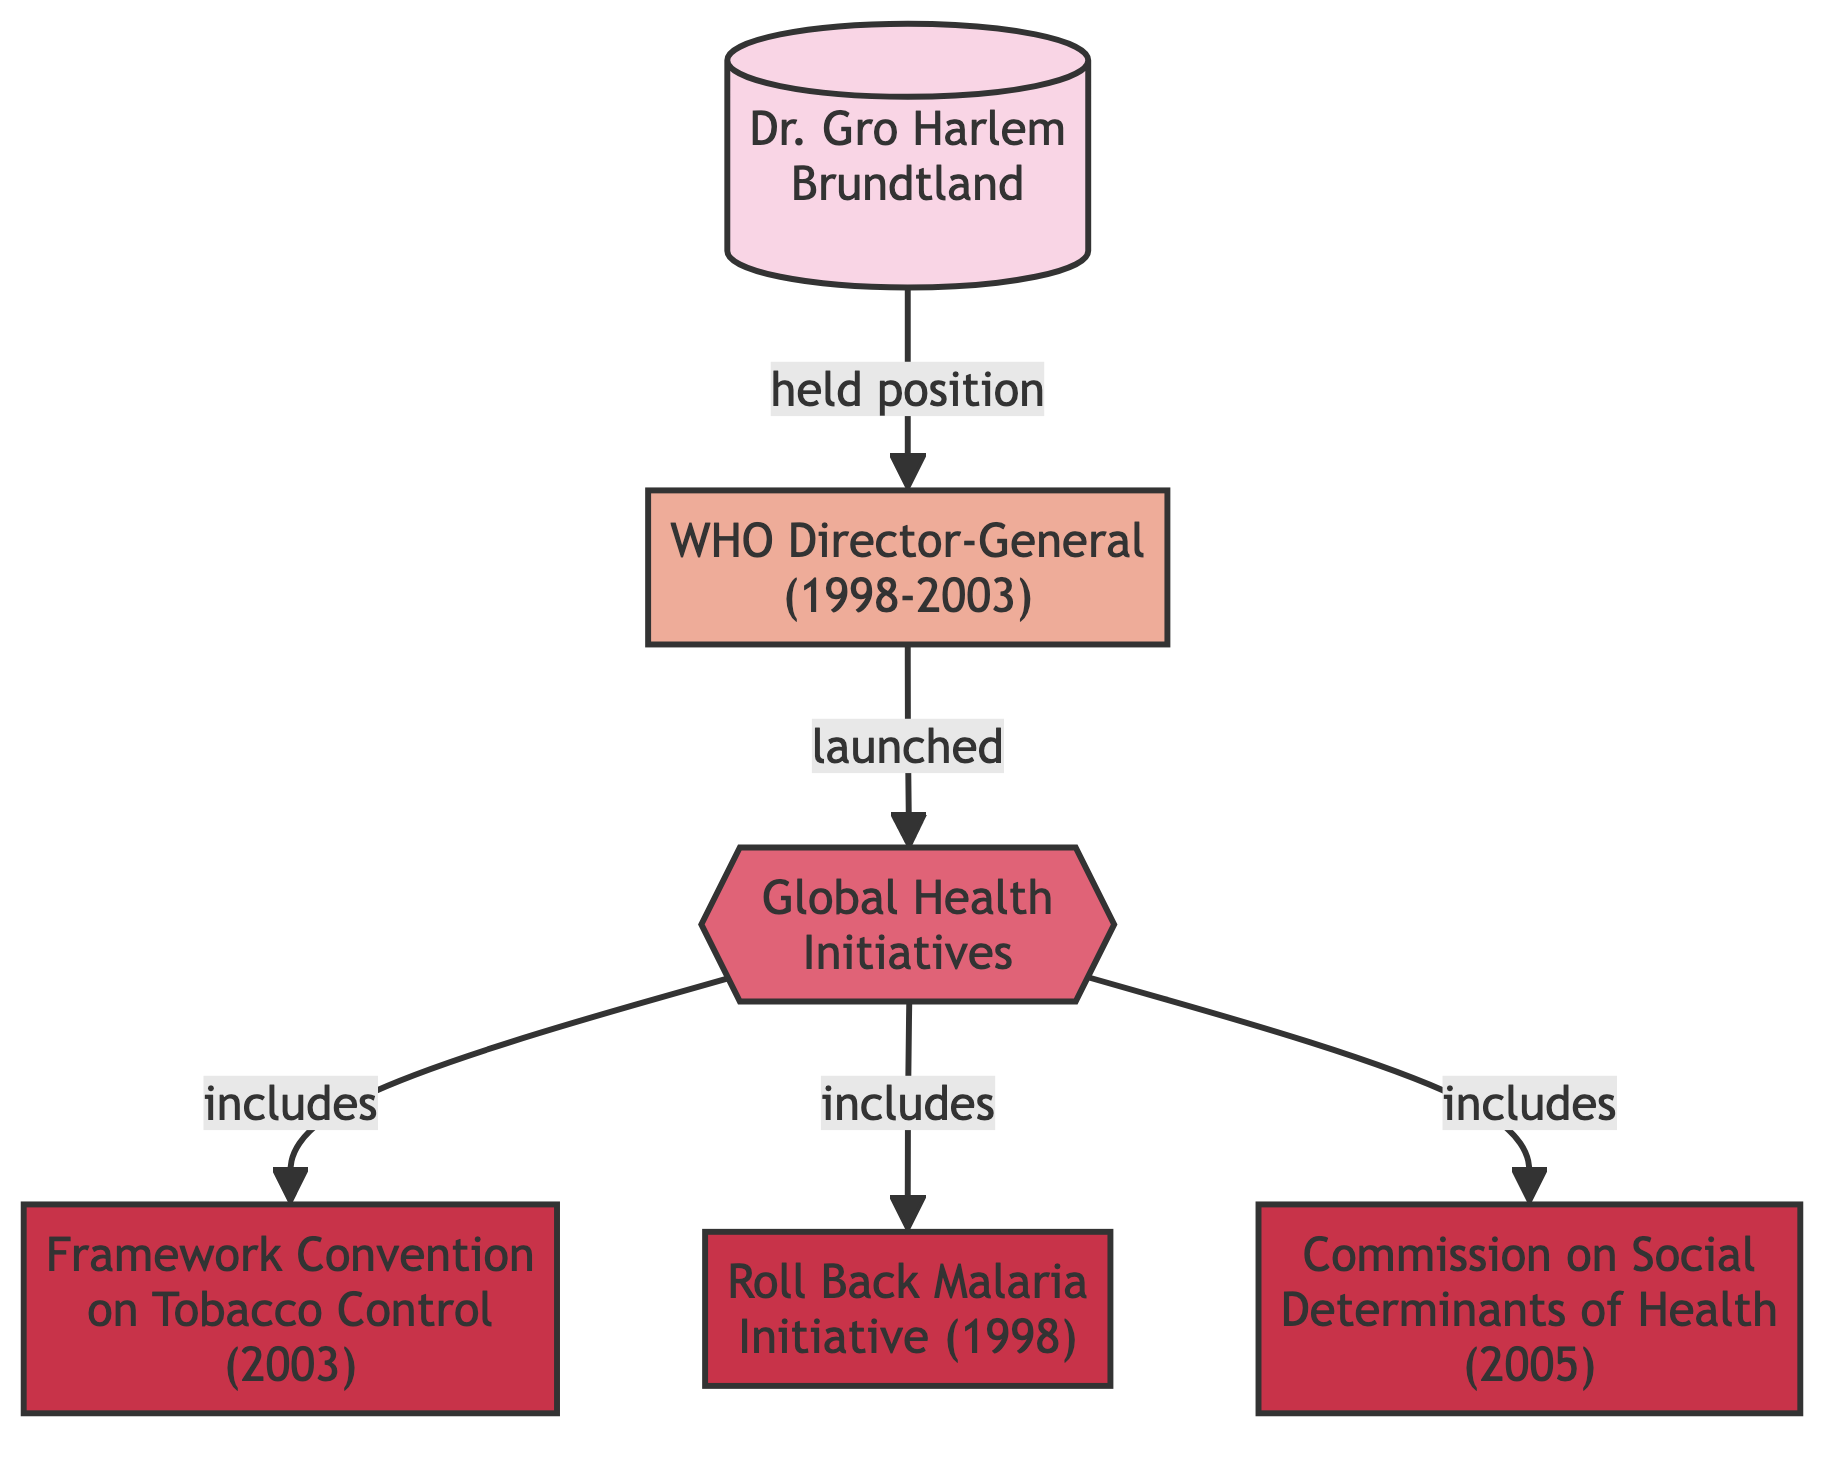What is the position Dr. Gro Harlem Brundtland held from 1998 to 2003? The diagram specifies that Dr. Gro Harlem Brundtland held the position of WHO Director-General during the years 1998 to 2003. This can be found indicated in the node connected directly to her.
Answer: WHO Director-General (1998-2003) How many global health initiatives are listed in the diagram? The diagram lists three global health initiatives that are included under the "Global Health Initiatives" category. By counting the initiative nodes (Framework Convention on Tobacco Control, Roll Back Malaria Initiative, and Commission on Social Determinants of Health), we can determine the total number.
Answer: 3 What initiative was launched in 2003? Based on the diagram, the Framework Convention on Tobacco Control is noted as an initiative that was launched in 2003. This is indicated in the node specifically mentioning the year 2003 alongside the initiative.
Answer: Framework Convention on Tobacco Control (2003) What connection exists between the WHO Director-General and the Global Health Initiatives? The diagram shows a direct connection labeled "launched" between the WHO Director-General node and the Global Health Initiatives category, indicating that the WHO Director-General was responsible for launching these initiatives.
Answer: launched Which initiative addresses social determinants? The diagram specifies the "Commission on Social Determinants of Health" as the initiative that addresses social determinants, indicated by the wording in the respective initiative node.
Answer: Commission on Social Determinants of Health (2005) 